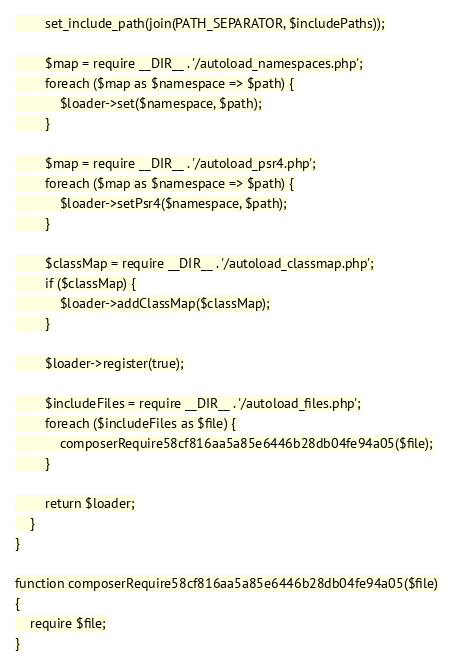<code> <loc_0><loc_0><loc_500><loc_500><_PHP_>        set_include_path(join(PATH_SEPARATOR, $includePaths));

        $map = require __DIR__ . '/autoload_namespaces.php';
        foreach ($map as $namespace => $path) {
            $loader->set($namespace, $path);
        }

        $map = require __DIR__ . '/autoload_psr4.php';
        foreach ($map as $namespace => $path) {
            $loader->setPsr4($namespace, $path);
        }

        $classMap = require __DIR__ . '/autoload_classmap.php';
        if ($classMap) {
            $loader->addClassMap($classMap);
        }

        $loader->register(true);

        $includeFiles = require __DIR__ . '/autoload_files.php';
        foreach ($includeFiles as $file) {
            composerRequire58cf816aa5a85e6446b28db04fe94a05($file);
        }

        return $loader;
    }
}

function composerRequire58cf816aa5a85e6446b28db04fe94a05($file)
{
    require $file;
}
</code> 